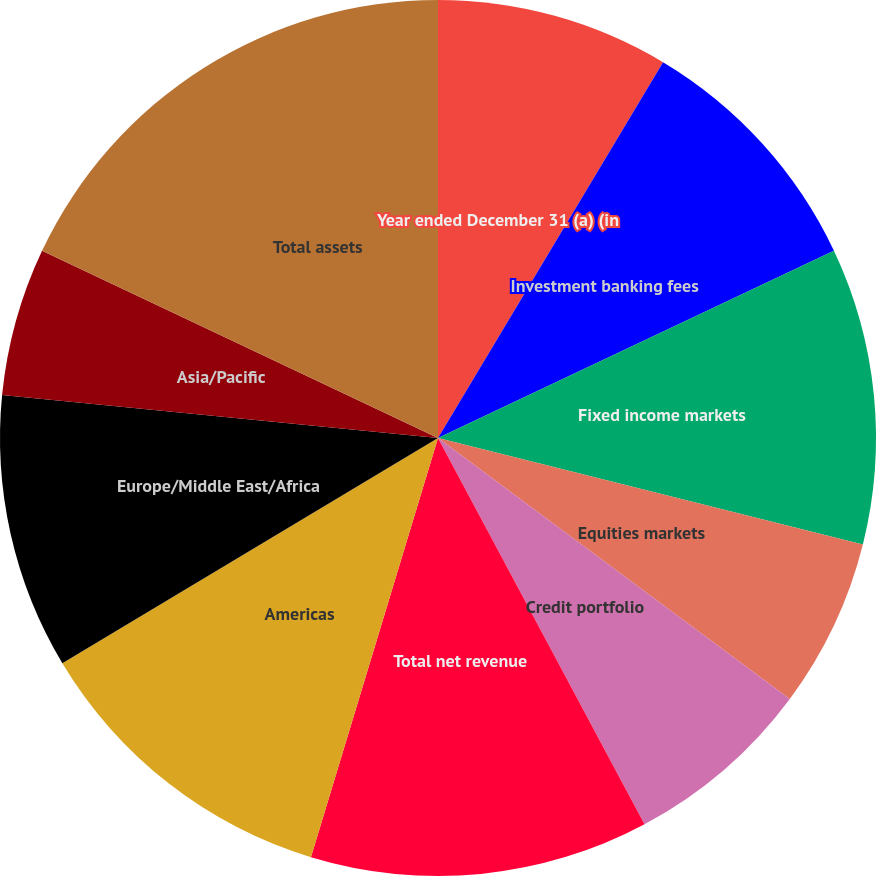<chart> <loc_0><loc_0><loc_500><loc_500><pie_chart><fcel>Year ended December 31 (a) (in<fcel>Investment banking fees<fcel>Fixed income markets<fcel>Equities markets<fcel>Credit portfolio<fcel>Total net revenue<fcel>Americas<fcel>Europe/Middle East/Africa<fcel>Asia/Pacific<fcel>Total assets<nl><fcel>8.59%<fcel>9.38%<fcel>10.94%<fcel>6.25%<fcel>7.03%<fcel>12.5%<fcel>11.72%<fcel>10.16%<fcel>5.47%<fcel>17.97%<nl></chart> 